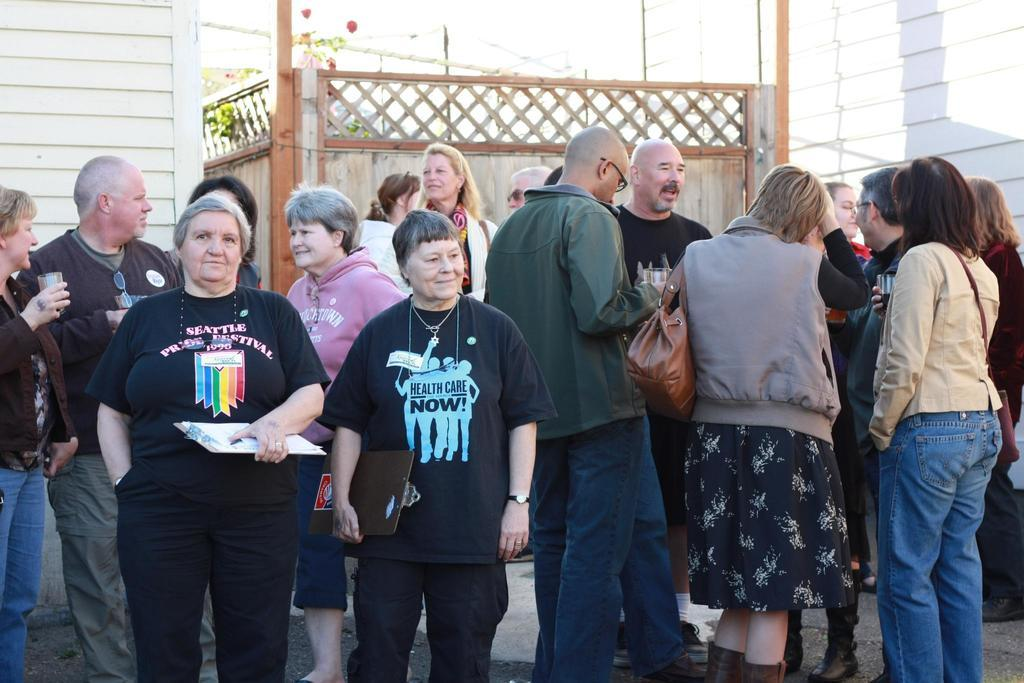What are the people in the image doing? The people in the image are standing on the road. What can be seen in the distance behind the people? There are buildings and plants visible in the background of the image. What type of chair is the representative sitting on in the image? There is no representative or chair present in the image; it only features people standing on the road and buildings and plants in the background. 